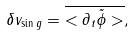Convert formula to latex. <formula><loc_0><loc_0><loc_500><loc_500>\delta v _ { \sin g } = \overline { < \partial _ { t } \tilde { \phi } > } ,</formula> 